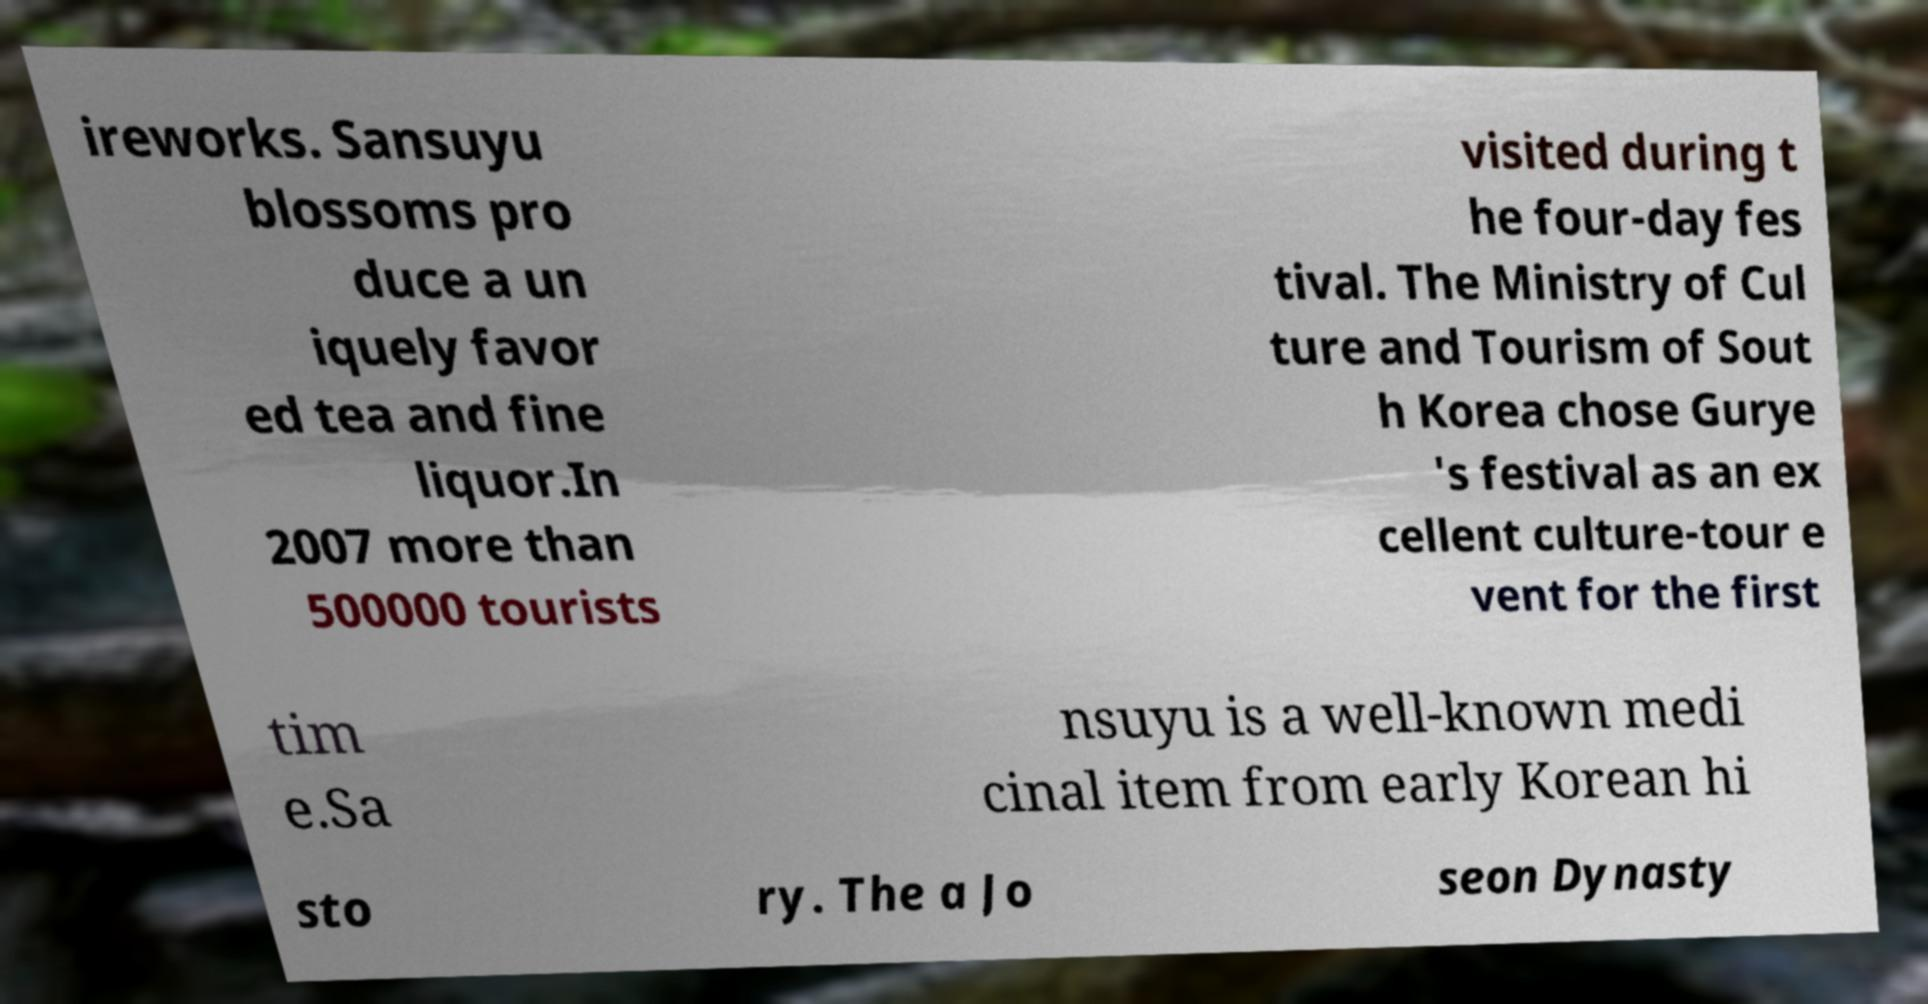Please identify and transcribe the text found in this image. ireworks. Sansuyu blossoms pro duce a un iquely favor ed tea and fine liquor.In 2007 more than 500000 tourists visited during t he four-day fes tival. The Ministry of Cul ture and Tourism of Sout h Korea chose Gurye 's festival as an ex cellent culture-tour e vent for the first tim e.Sa nsuyu is a well-known medi cinal item from early Korean hi sto ry. The a Jo seon Dynasty 